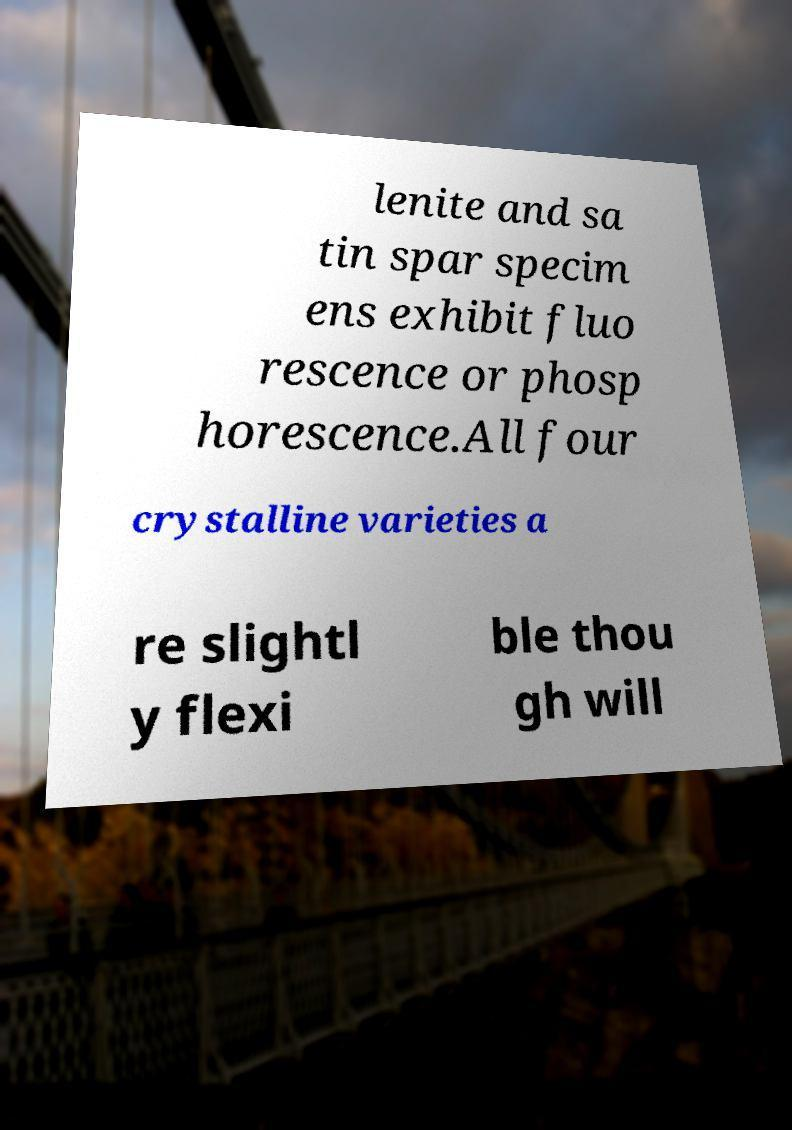Could you extract and type out the text from this image? lenite and sa tin spar specim ens exhibit fluo rescence or phosp horescence.All four crystalline varieties a re slightl y flexi ble thou gh will 